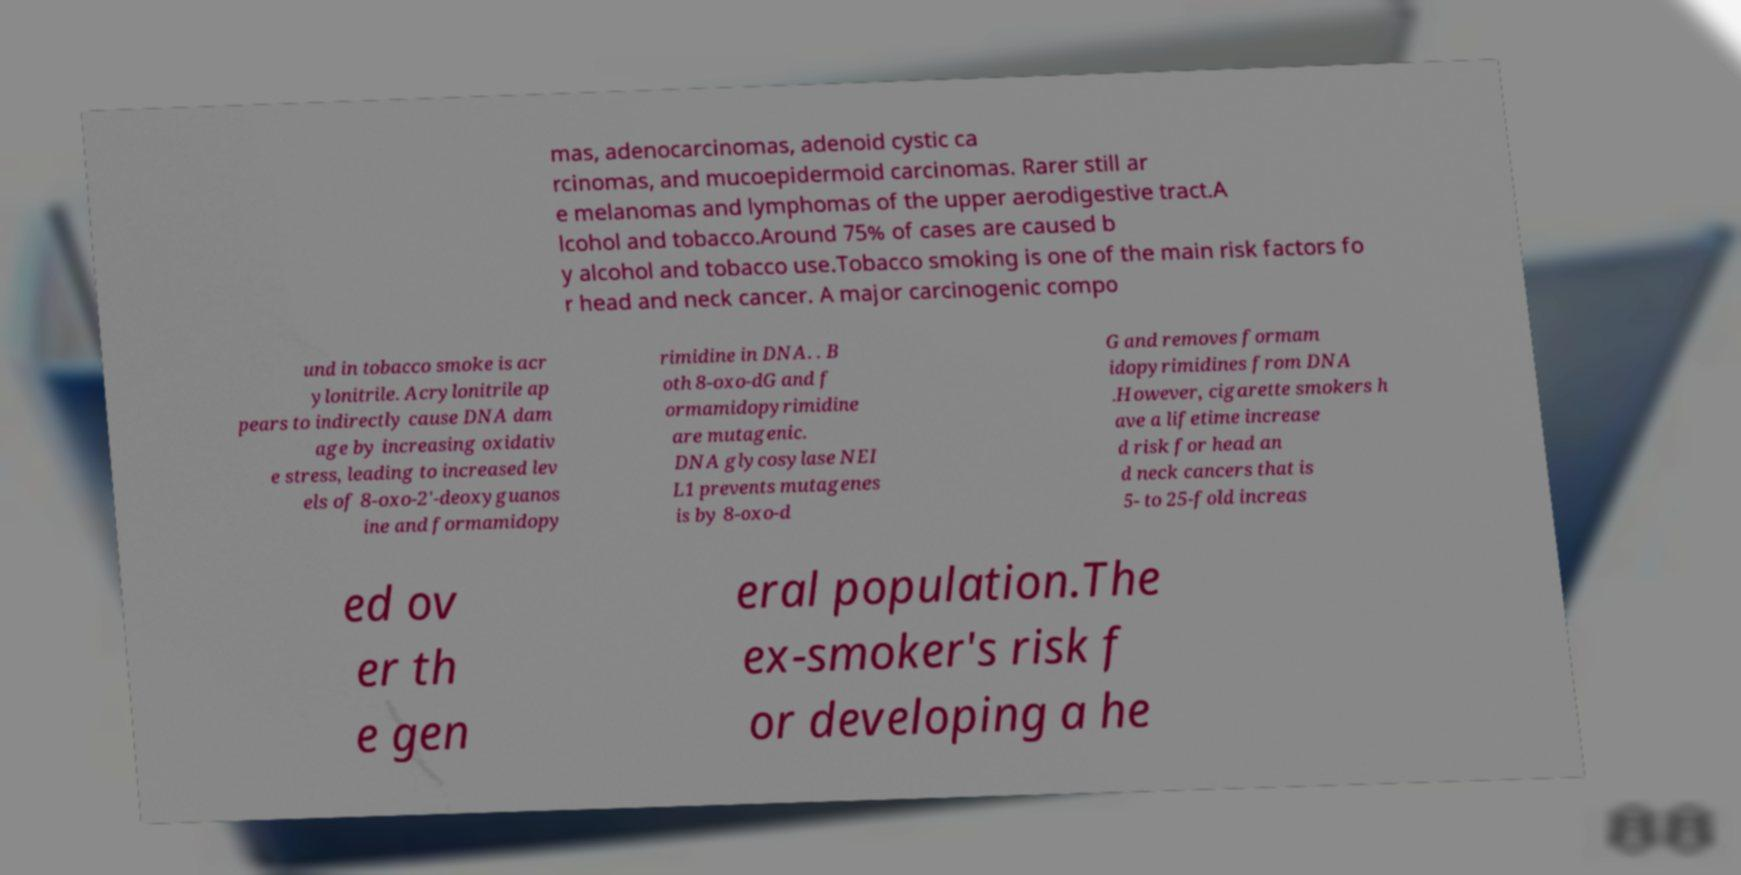Could you assist in decoding the text presented in this image and type it out clearly? mas, adenocarcinomas, adenoid cystic ca rcinomas, and mucoepidermoid carcinomas. Rarer still ar e melanomas and lymphomas of the upper aerodigestive tract.A lcohol and tobacco.Around 75% of cases are caused b y alcohol and tobacco use.Tobacco smoking is one of the main risk factors fo r head and neck cancer. A major carcinogenic compo und in tobacco smoke is acr ylonitrile. Acrylonitrile ap pears to indirectly cause DNA dam age by increasing oxidativ e stress, leading to increased lev els of 8-oxo-2'-deoxyguanos ine and formamidopy rimidine in DNA. . B oth 8-oxo-dG and f ormamidopyrimidine are mutagenic. DNA glycosylase NEI L1 prevents mutagenes is by 8-oxo-d G and removes formam idopyrimidines from DNA .However, cigarette smokers h ave a lifetime increase d risk for head an d neck cancers that is 5- to 25-fold increas ed ov er th e gen eral population.The ex-smoker's risk f or developing a he 